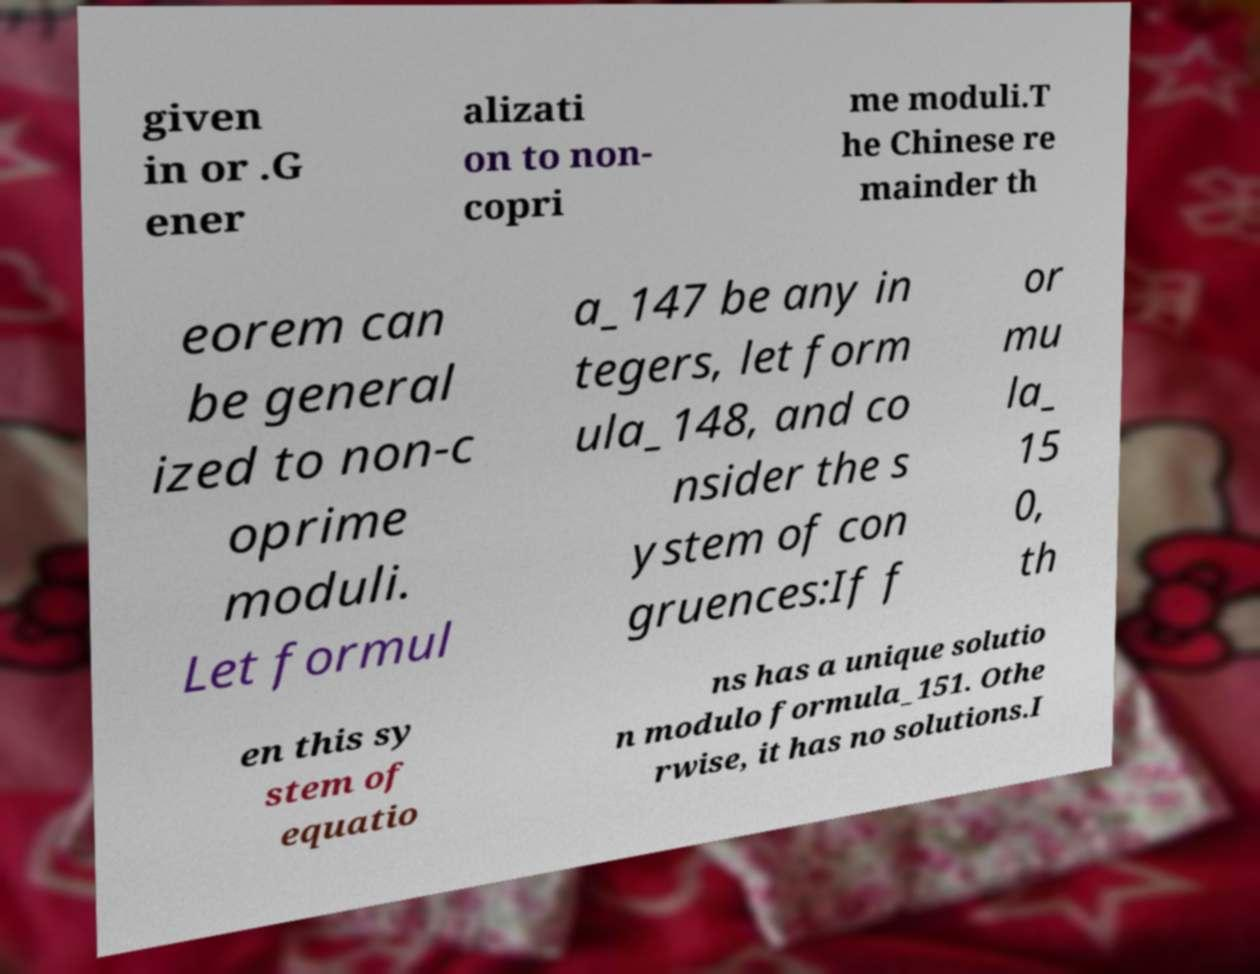I need the written content from this picture converted into text. Can you do that? given in or .G ener alizati on to non- copri me moduli.T he Chinese re mainder th eorem can be general ized to non-c oprime moduli. Let formul a_147 be any in tegers, let form ula_148, and co nsider the s ystem of con gruences:If f or mu la_ 15 0, th en this sy stem of equatio ns has a unique solutio n modulo formula_151. Othe rwise, it has no solutions.I 